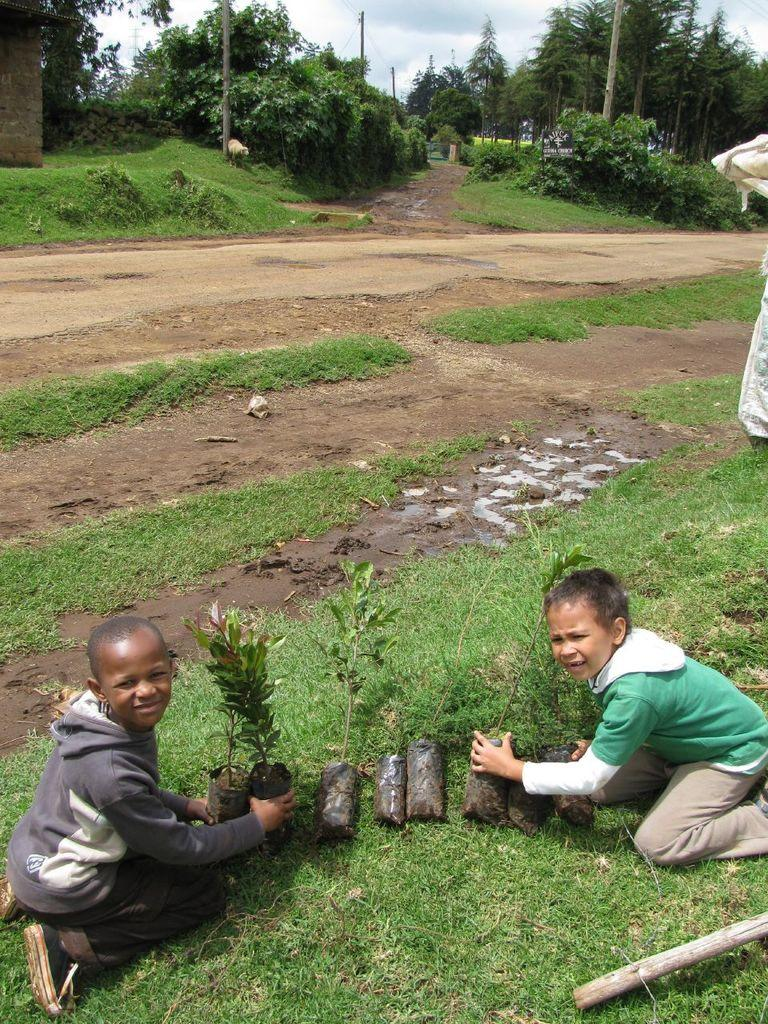Who is the main subject in the image? There is a boy in the image. What is the boy doing in the image? The boy is sitting on someone's knees. What is the boy holding in the image? The boy is holding plants. What can be seen in the background of the image? There are plants, trees, poles, and the sky visible in the background of the image. What is the condition of the sky in the image? Clouds are present in the sky. What type of boats can be seen sailing in the image? There are no boats present in the image. How does the boy rub his hands together in the image? The boy is not rubbing his hands together in the image; he is holding plants. 